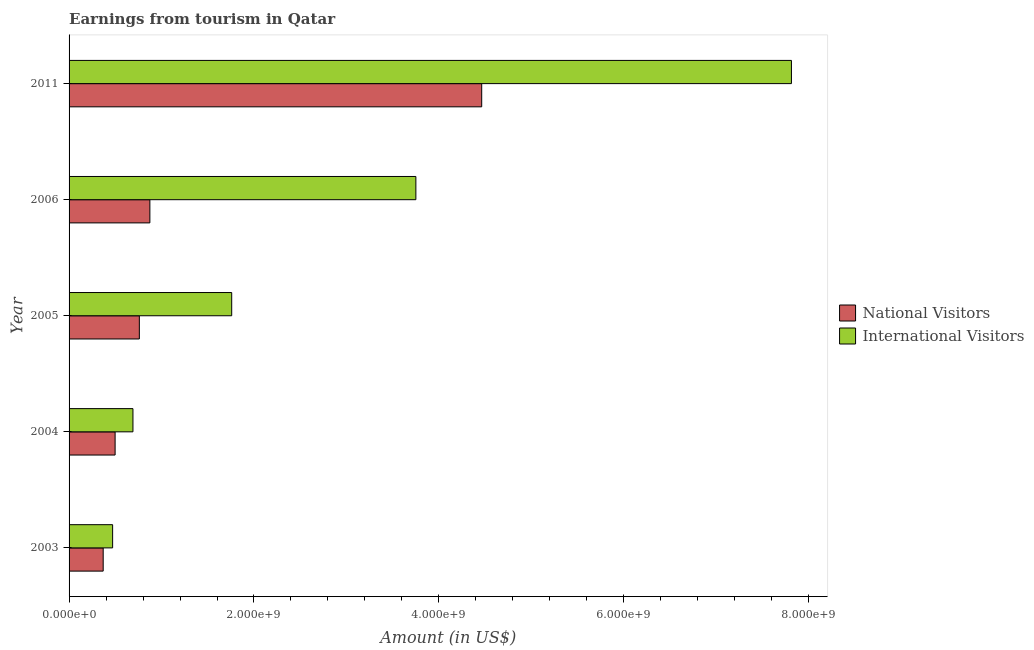How many different coloured bars are there?
Your response must be concise. 2. How many groups of bars are there?
Offer a very short reply. 5. Are the number of bars per tick equal to the number of legend labels?
Keep it short and to the point. Yes. Are the number of bars on each tick of the Y-axis equal?
Ensure brevity in your answer.  Yes. How many bars are there on the 3rd tick from the bottom?
Offer a terse response. 2. What is the label of the 4th group of bars from the top?
Your response must be concise. 2004. What is the amount earned from international visitors in 2006?
Make the answer very short. 3.75e+09. Across all years, what is the maximum amount earned from national visitors?
Ensure brevity in your answer.  4.46e+09. Across all years, what is the minimum amount earned from national visitors?
Ensure brevity in your answer.  3.69e+08. In which year was the amount earned from national visitors maximum?
Offer a terse response. 2011. In which year was the amount earned from national visitors minimum?
Your answer should be compact. 2003. What is the total amount earned from international visitors in the graph?
Keep it short and to the point. 1.45e+1. What is the difference between the amount earned from international visitors in 2004 and that in 2011?
Offer a very short reply. -7.12e+09. What is the difference between the amount earned from international visitors in 2004 and the amount earned from national visitors in 2003?
Offer a very short reply. 3.22e+08. What is the average amount earned from international visitors per year?
Your answer should be compact. 2.90e+09. In the year 2004, what is the difference between the amount earned from international visitors and amount earned from national visitors?
Offer a terse response. 1.93e+08. In how many years, is the amount earned from national visitors greater than 4400000000 US$?
Your answer should be compact. 1. What is the ratio of the amount earned from national visitors in 2003 to that in 2011?
Your answer should be very brief. 0.08. What is the difference between the highest and the second highest amount earned from international visitors?
Keep it short and to the point. 4.06e+09. What is the difference between the highest and the lowest amount earned from international visitors?
Your answer should be very brief. 7.34e+09. Is the sum of the amount earned from international visitors in 2004 and 2005 greater than the maximum amount earned from national visitors across all years?
Your answer should be compact. No. What does the 1st bar from the top in 2004 represents?
Offer a very short reply. International Visitors. What does the 1st bar from the bottom in 2003 represents?
Your answer should be compact. National Visitors. How many bars are there?
Offer a very short reply. 10. How many years are there in the graph?
Give a very brief answer. 5. What is the difference between two consecutive major ticks on the X-axis?
Provide a short and direct response. 2.00e+09. Are the values on the major ticks of X-axis written in scientific E-notation?
Ensure brevity in your answer.  Yes. How are the legend labels stacked?
Provide a succinct answer. Vertical. What is the title of the graph?
Give a very brief answer. Earnings from tourism in Qatar. Does "All education staff compensation" appear as one of the legend labels in the graph?
Your response must be concise. No. What is the Amount (in US$) of National Visitors in 2003?
Ensure brevity in your answer.  3.69e+08. What is the Amount (in US$) of International Visitors in 2003?
Keep it short and to the point. 4.71e+08. What is the Amount (in US$) in National Visitors in 2004?
Ensure brevity in your answer.  4.98e+08. What is the Amount (in US$) in International Visitors in 2004?
Your response must be concise. 6.91e+08. What is the Amount (in US$) in National Visitors in 2005?
Your answer should be very brief. 7.60e+08. What is the Amount (in US$) of International Visitors in 2005?
Offer a very short reply. 1.76e+09. What is the Amount (in US$) of National Visitors in 2006?
Provide a succinct answer. 8.74e+08. What is the Amount (in US$) of International Visitors in 2006?
Keep it short and to the point. 3.75e+09. What is the Amount (in US$) in National Visitors in 2011?
Make the answer very short. 4.46e+09. What is the Amount (in US$) in International Visitors in 2011?
Your response must be concise. 7.81e+09. Across all years, what is the maximum Amount (in US$) of National Visitors?
Your answer should be compact. 4.46e+09. Across all years, what is the maximum Amount (in US$) in International Visitors?
Provide a short and direct response. 7.81e+09. Across all years, what is the minimum Amount (in US$) of National Visitors?
Keep it short and to the point. 3.69e+08. Across all years, what is the minimum Amount (in US$) in International Visitors?
Provide a succinct answer. 4.71e+08. What is the total Amount (in US$) of National Visitors in the graph?
Offer a terse response. 6.96e+09. What is the total Amount (in US$) of International Visitors in the graph?
Offer a very short reply. 1.45e+1. What is the difference between the Amount (in US$) of National Visitors in 2003 and that in 2004?
Your answer should be very brief. -1.29e+08. What is the difference between the Amount (in US$) in International Visitors in 2003 and that in 2004?
Make the answer very short. -2.20e+08. What is the difference between the Amount (in US$) in National Visitors in 2003 and that in 2005?
Provide a short and direct response. -3.91e+08. What is the difference between the Amount (in US$) of International Visitors in 2003 and that in 2005?
Give a very brief answer. -1.29e+09. What is the difference between the Amount (in US$) in National Visitors in 2003 and that in 2006?
Make the answer very short. -5.05e+08. What is the difference between the Amount (in US$) in International Visitors in 2003 and that in 2006?
Ensure brevity in your answer.  -3.28e+09. What is the difference between the Amount (in US$) in National Visitors in 2003 and that in 2011?
Ensure brevity in your answer.  -4.09e+09. What is the difference between the Amount (in US$) in International Visitors in 2003 and that in 2011?
Your answer should be compact. -7.34e+09. What is the difference between the Amount (in US$) in National Visitors in 2004 and that in 2005?
Give a very brief answer. -2.62e+08. What is the difference between the Amount (in US$) in International Visitors in 2004 and that in 2005?
Provide a short and direct response. -1.07e+09. What is the difference between the Amount (in US$) of National Visitors in 2004 and that in 2006?
Your answer should be very brief. -3.76e+08. What is the difference between the Amount (in US$) in International Visitors in 2004 and that in 2006?
Make the answer very short. -3.06e+09. What is the difference between the Amount (in US$) in National Visitors in 2004 and that in 2011?
Your answer should be very brief. -3.96e+09. What is the difference between the Amount (in US$) in International Visitors in 2004 and that in 2011?
Ensure brevity in your answer.  -7.12e+09. What is the difference between the Amount (in US$) in National Visitors in 2005 and that in 2006?
Provide a succinct answer. -1.14e+08. What is the difference between the Amount (in US$) in International Visitors in 2005 and that in 2006?
Give a very brief answer. -1.99e+09. What is the difference between the Amount (in US$) of National Visitors in 2005 and that in 2011?
Ensure brevity in your answer.  -3.70e+09. What is the difference between the Amount (in US$) of International Visitors in 2005 and that in 2011?
Keep it short and to the point. -6.05e+09. What is the difference between the Amount (in US$) of National Visitors in 2006 and that in 2011?
Ensure brevity in your answer.  -3.59e+09. What is the difference between the Amount (in US$) of International Visitors in 2006 and that in 2011?
Provide a succinct answer. -4.06e+09. What is the difference between the Amount (in US$) of National Visitors in 2003 and the Amount (in US$) of International Visitors in 2004?
Give a very brief answer. -3.22e+08. What is the difference between the Amount (in US$) of National Visitors in 2003 and the Amount (in US$) of International Visitors in 2005?
Your answer should be compact. -1.39e+09. What is the difference between the Amount (in US$) of National Visitors in 2003 and the Amount (in US$) of International Visitors in 2006?
Provide a short and direct response. -3.38e+09. What is the difference between the Amount (in US$) in National Visitors in 2003 and the Amount (in US$) in International Visitors in 2011?
Offer a terse response. -7.44e+09. What is the difference between the Amount (in US$) of National Visitors in 2004 and the Amount (in US$) of International Visitors in 2005?
Ensure brevity in your answer.  -1.26e+09. What is the difference between the Amount (in US$) of National Visitors in 2004 and the Amount (in US$) of International Visitors in 2006?
Give a very brief answer. -3.25e+09. What is the difference between the Amount (in US$) of National Visitors in 2004 and the Amount (in US$) of International Visitors in 2011?
Provide a short and direct response. -7.32e+09. What is the difference between the Amount (in US$) of National Visitors in 2005 and the Amount (in US$) of International Visitors in 2006?
Provide a short and direct response. -2.99e+09. What is the difference between the Amount (in US$) in National Visitors in 2005 and the Amount (in US$) in International Visitors in 2011?
Ensure brevity in your answer.  -7.05e+09. What is the difference between the Amount (in US$) of National Visitors in 2006 and the Amount (in US$) of International Visitors in 2011?
Provide a short and direct response. -6.94e+09. What is the average Amount (in US$) in National Visitors per year?
Provide a short and direct response. 1.39e+09. What is the average Amount (in US$) of International Visitors per year?
Give a very brief answer. 2.90e+09. In the year 2003, what is the difference between the Amount (in US$) in National Visitors and Amount (in US$) in International Visitors?
Offer a terse response. -1.02e+08. In the year 2004, what is the difference between the Amount (in US$) of National Visitors and Amount (in US$) of International Visitors?
Offer a very short reply. -1.93e+08. In the year 2005, what is the difference between the Amount (in US$) in National Visitors and Amount (in US$) in International Visitors?
Provide a succinct answer. -9.99e+08. In the year 2006, what is the difference between the Amount (in US$) in National Visitors and Amount (in US$) in International Visitors?
Your answer should be very brief. -2.88e+09. In the year 2011, what is the difference between the Amount (in US$) in National Visitors and Amount (in US$) in International Visitors?
Ensure brevity in your answer.  -3.35e+09. What is the ratio of the Amount (in US$) in National Visitors in 2003 to that in 2004?
Offer a very short reply. 0.74. What is the ratio of the Amount (in US$) of International Visitors in 2003 to that in 2004?
Offer a terse response. 0.68. What is the ratio of the Amount (in US$) of National Visitors in 2003 to that in 2005?
Ensure brevity in your answer.  0.49. What is the ratio of the Amount (in US$) of International Visitors in 2003 to that in 2005?
Give a very brief answer. 0.27. What is the ratio of the Amount (in US$) in National Visitors in 2003 to that in 2006?
Your answer should be compact. 0.42. What is the ratio of the Amount (in US$) of International Visitors in 2003 to that in 2006?
Ensure brevity in your answer.  0.13. What is the ratio of the Amount (in US$) in National Visitors in 2003 to that in 2011?
Your response must be concise. 0.08. What is the ratio of the Amount (in US$) of International Visitors in 2003 to that in 2011?
Provide a short and direct response. 0.06. What is the ratio of the Amount (in US$) of National Visitors in 2004 to that in 2005?
Make the answer very short. 0.66. What is the ratio of the Amount (in US$) of International Visitors in 2004 to that in 2005?
Make the answer very short. 0.39. What is the ratio of the Amount (in US$) of National Visitors in 2004 to that in 2006?
Make the answer very short. 0.57. What is the ratio of the Amount (in US$) of International Visitors in 2004 to that in 2006?
Provide a succinct answer. 0.18. What is the ratio of the Amount (in US$) in National Visitors in 2004 to that in 2011?
Provide a succinct answer. 0.11. What is the ratio of the Amount (in US$) of International Visitors in 2004 to that in 2011?
Your answer should be compact. 0.09. What is the ratio of the Amount (in US$) of National Visitors in 2005 to that in 2006?
Offer a very short reply. 0.87. What is the ratio of the Amount (in US$) of International Visitors in 2005 to that in 2006?
Ensure brevity in your answer.  0.47. What is the ratio of the Amount (in US$) in National Visitors in 2005 to that in 2011?
Give a very brief answer. 0.17. What is the ratio of the Amount (in US$) in International Visitors in 2005 to that in 2011?
Make the answer very short. 0.23. What is the ratio of the Amount (in US$) in National Visitors in 2006 to that in 2011?
Your answer should be compact. 0.2. What is the ratio of the Amount (in US$) of International Visitors in 2006 to that in 2011?
Give a very brief answer. 0.48. What is the difference between the highest and the second highest Amount (in US$) of National Visitors?
Your response must be concise. 3.59e+09. What is the difference between the highest and the second highest Amount (in US$) of International Visitors?
Your answer should be compact. 4.06e+09. What is the difference between the highest and the lowest Amount (in US$) of National Visitors?
Offer a terse response. 4.09e+09. What is the difference between the highest and the lowest Amount (in US$) in International Visitors?
Offer a terse response. 7.34e+09. 